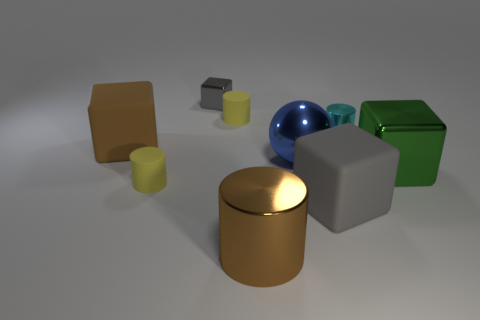Subtract all small cyan cylinders. How many cylinders are left? 3 Subtract 1 cubes. How many cubes are left? 3 Subtract all cyan cylinders. How many cylinders are left? 3 Subtract all spheres. How many objects are left? 8 Subtract all green balls. How many brown cylinders are left? 1 Subtract all big gray things. Subtract all big blue balls. How many objects are left? 7 Add 5 gray matte things. How many gray matte things are left? 6 Add 6 yellow rubber objects. How many yellow rubber objects exist? 8 Subtract 0 green cylinders. How many objects are left? 9 Subtract all yellow blocks. Subtract all red cylinders. How many blocks are left? 4 